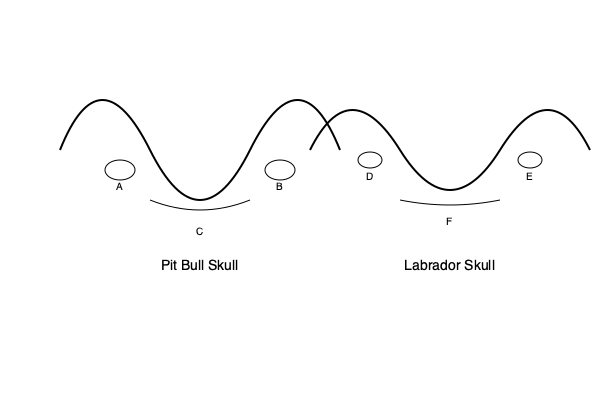Based on the labeled diagrams of Pit Bull and Labrador skulls, which anatomical feature is most likely to contribute to the perception of Pit Bulls as potentially more dangerous, and how does this feature differ between the two breeds? To answer this question, we need to analyze the anatomical differences between the Pit Bull and Labrador skulls:

1. Skull shape:
   - Pit Bull (left): The skull has a more pronounced curve (brachycephalic), with a shorter and broader appearance.
   - Labrador (right): The skull has a more elongated shape (mesocephalic or dolichocephalic).

2. Eye sockets (orbits):
   - Pit Bull (A and B): Larger and more pronounced.
   - Labrador (D and E): Smaller and less prominent.

3. Jaw structure:
   - Pit Bull (C): The jaw appears broader and more muscular.
   - Labrador (F): The jaw is relatively narrower and less pronounced.

The most significant feature contributing to the perception of Pit Bulls as potentially more dangerous is the jaw structure (C and F). The Pit Bull's broader and more muscular jaw can create a stronger bite force, which may be associated with increased potential for injury.

This anatomical difference is due to selective breeding in Pit Bulls for traits such as strength and tenacity, originally for purposes like bull-baiting. However, it's crucial to note that behavior is influenced by multiple factors, including training, socialization, and individual temperament, not just physical characteristics.

The broader skull and larger eye sockets in Pit Bulls may also contribute to their distinctive appearance, which some people find intimidating. However, these features do not directly correlate with aggressive behavior.

It's important to remember that while these anatomical differences exist, they do not predetermine a dog's behavior or likelihood to be dangerous. Proper training, socialization, and responsible ownership are key factors in any dog's behavior, regardless of breed.
Answer: Jaw structure; Pit Bulls have a broader, more muscular jaw compared to Labradors. 